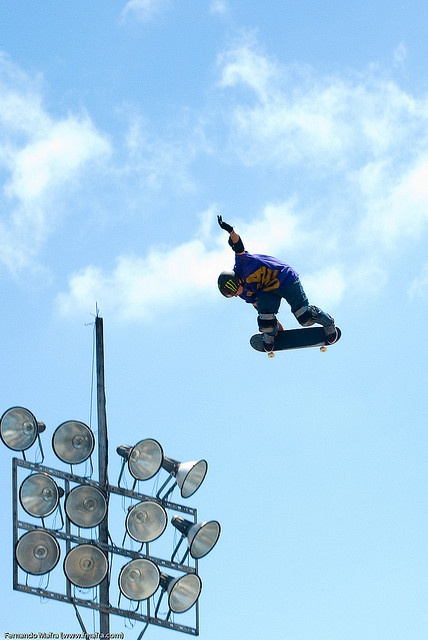Describe the objects in this image and their specific colors. I can see people in lightblue, black, navy, gray, and olive tones and skateboard in lightblue, black, darkblue, gray, and blue tones in this image. 